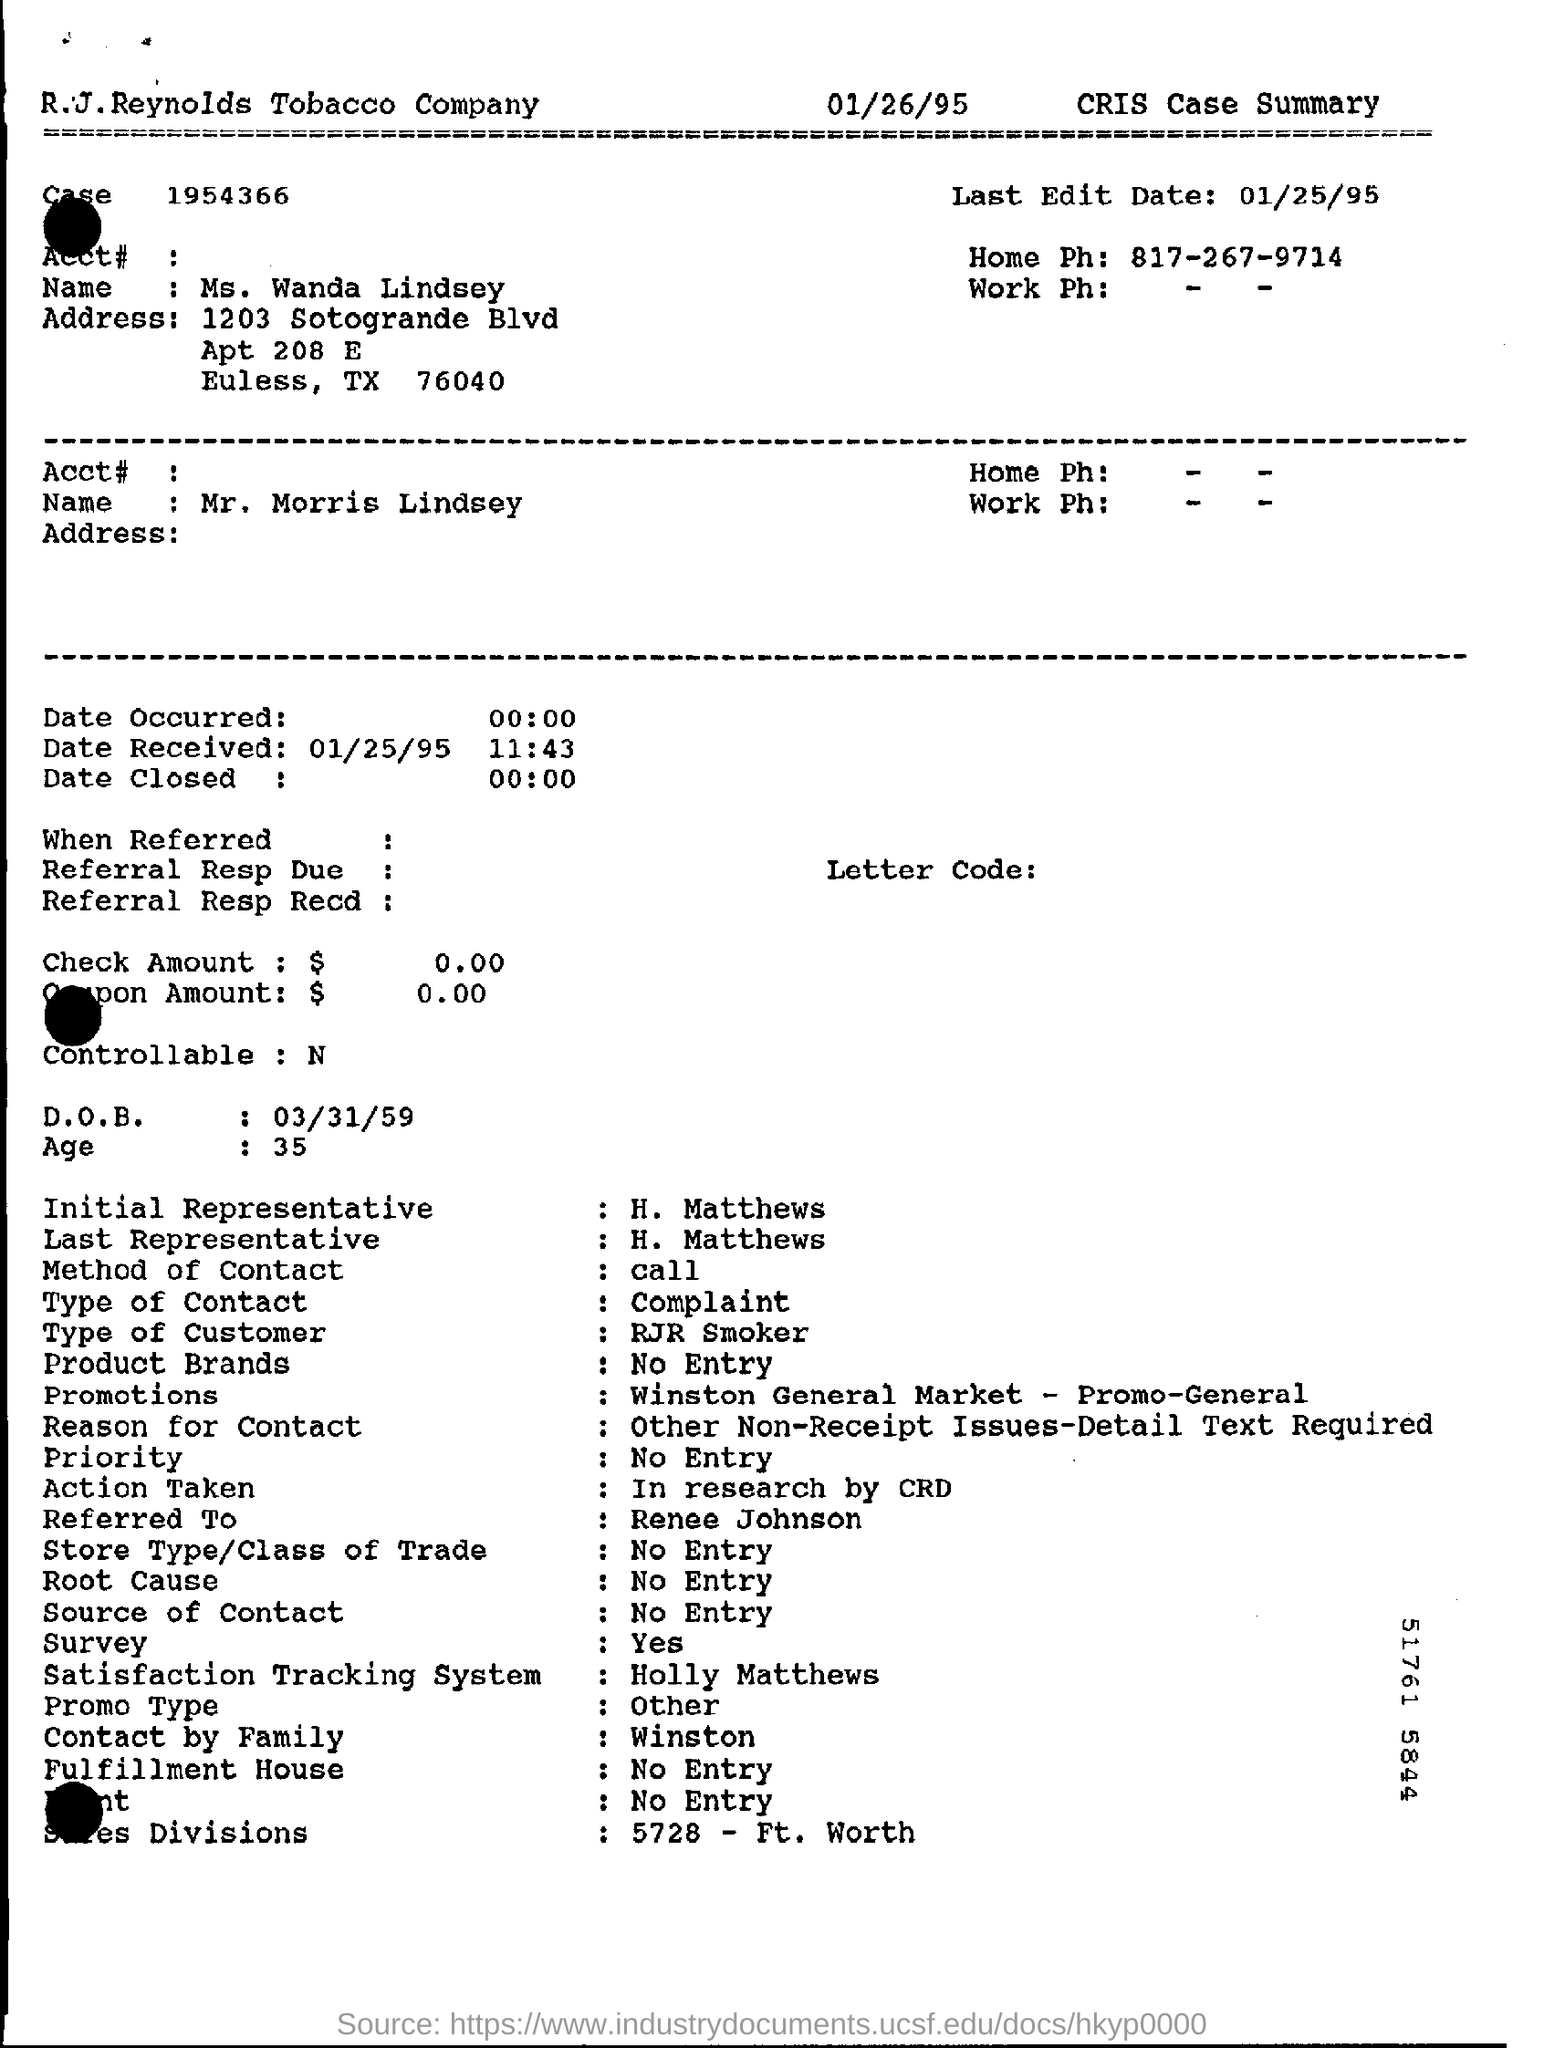Give some essential details in this illustration. As of January 25, 1995, the last edit has been made. The case number is 1954366... The type of contact is a complaint. The method of contact is by call. 